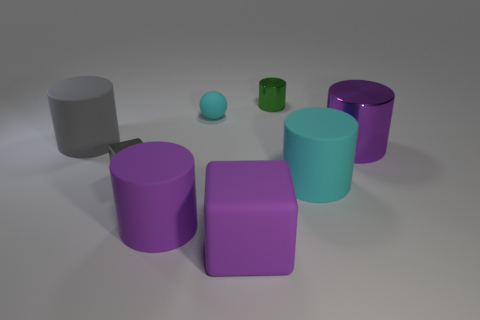What can you infer about the setting of these objects based on the shadows and lighting? The shadows and the soft diffused lighting suggest that the objects are placed in an indoor setting with a light source positioned above them, perhaps in a controlled studio environment. 